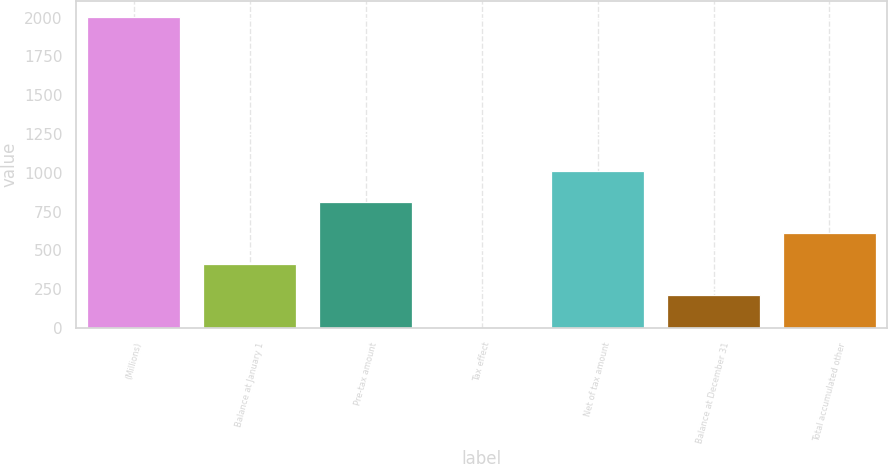<chart> <loc_0><loc_0><loc_500><loc_500><bar_chart><fcel>(Millions)<fcel>Balance at January 1<fcel>Pre-tax amount<fcel>Tax effect<fcel>Net of tax amount<fcel>Balance at December 31<fcel>Total accumulated other<nl><fcel>2006<fcel>410.3<fcel>810.9<fcel>3<fcel>1011.2<fcel>210<fcel>610.6<nl></chart> 